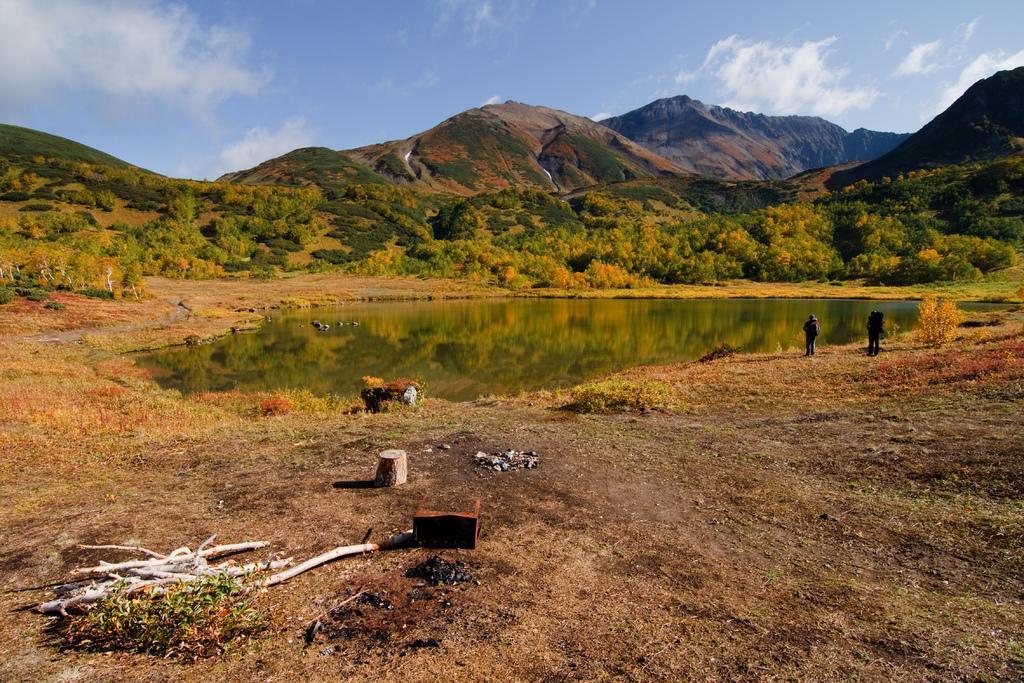Can you describe this image briefly? In this image we can see wood on the land. In the middle of the image we can see water body. There are two men standing on the land on the right side of the image. Background of the image, we can see planets and mountains. At the top of the image, we can see the sky with some clouds. 